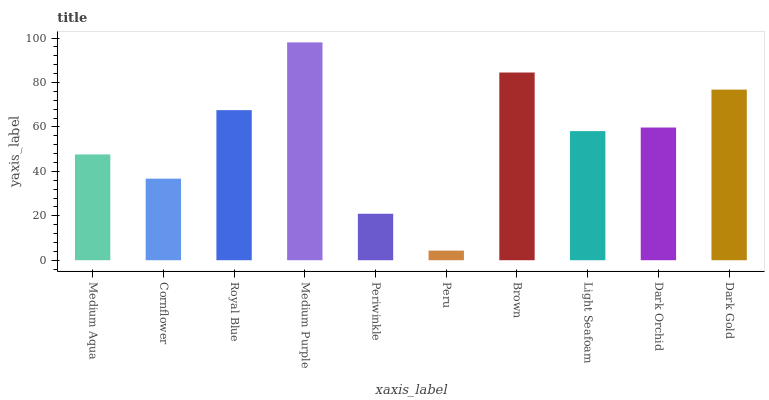Is Peru the minimum?
Answer yes or no. Yes. Is Medium Purple the maximum?
Answer yes or no. Yes. Is Cornflower the minimum?
Answer yes or no. No. Is Cornflower the maximum?
Answer yes or no. No. Is Medium Aqua greater than Cornflower?
Answer yes or no. Yes. Is Cornflower less than Medium Aqua?
Answer yes or no. Yes. Is Cornflower greater than Medium Aqua?
Answer yes or no. No. Is Medium Aqua less than Cornflower?
Answer yes or no. No. Is Dark Orchid the high median?
Answer yes or no. Yes. Is Light Seafoam the low median?
Answer yes or no. Yes. Is Medium Aqua the high median?
Answer yes or no. No. Is Peru the low median?
Answer yes or no. No. 